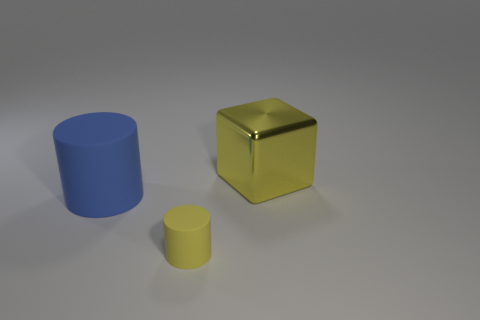Add 1 big things. How many objects exist? 4 Subtract all cylinders. How many objects are left? 1 Add 2 large blue cylinders. How many large blue cylinders are left? 3 Add 1 brown metallic cylinders. How many brown metallic cylinders exist? 1 Subtract 0 green blocks. How many objects are left? 3 Subtract all shiny blocks. Subtract all yellow metallic objects. How many objects are left? 1 